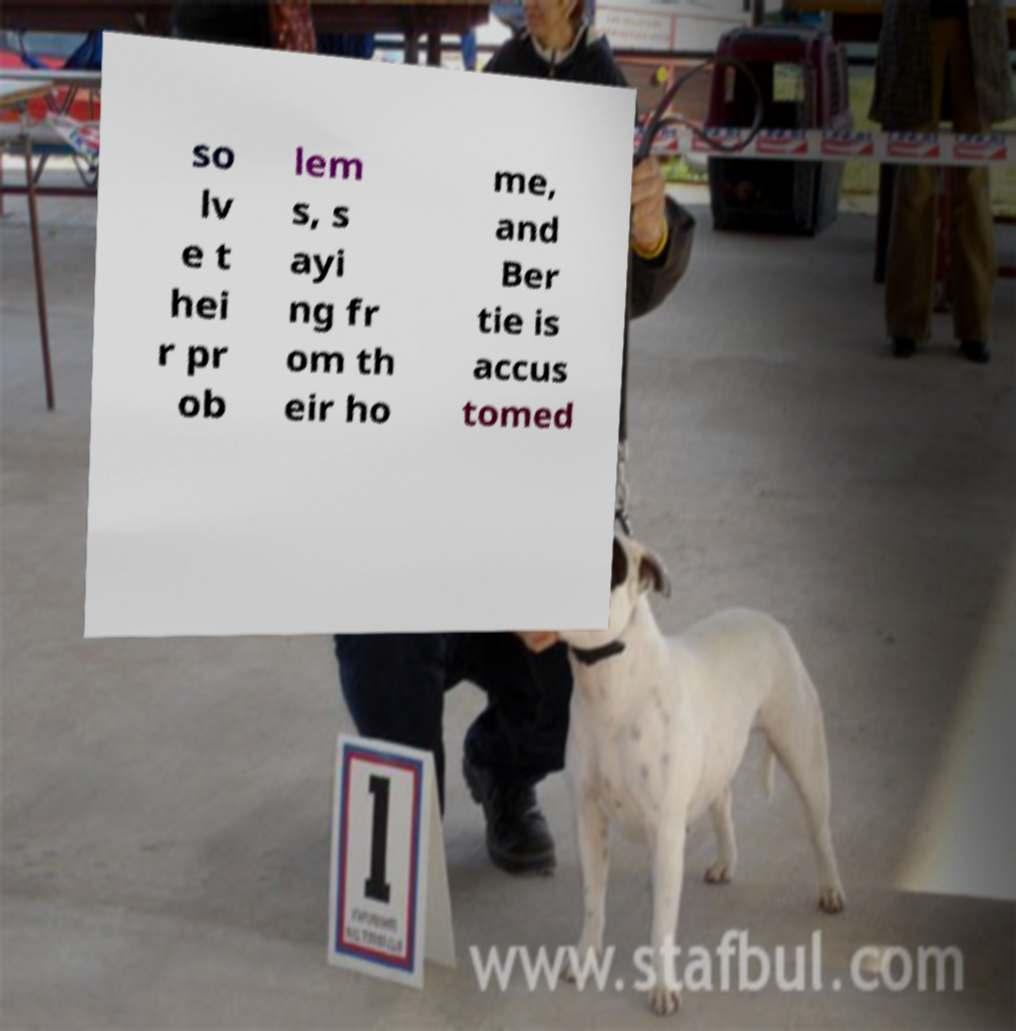Please read and relay the text visible in this image. What does it say? so lv e t hei r pr ob lem s, s ayi ng fr om th eir ho me, and Ber tie is accus tomed 